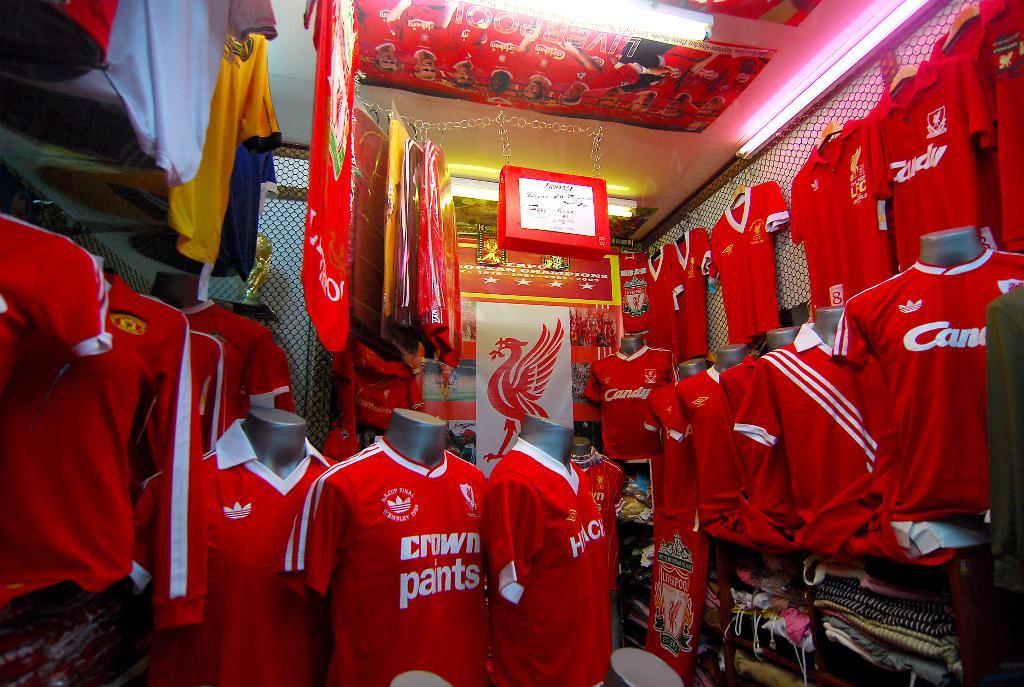What color are the letters on the red shirts?
Provide a short and direct response. White. 